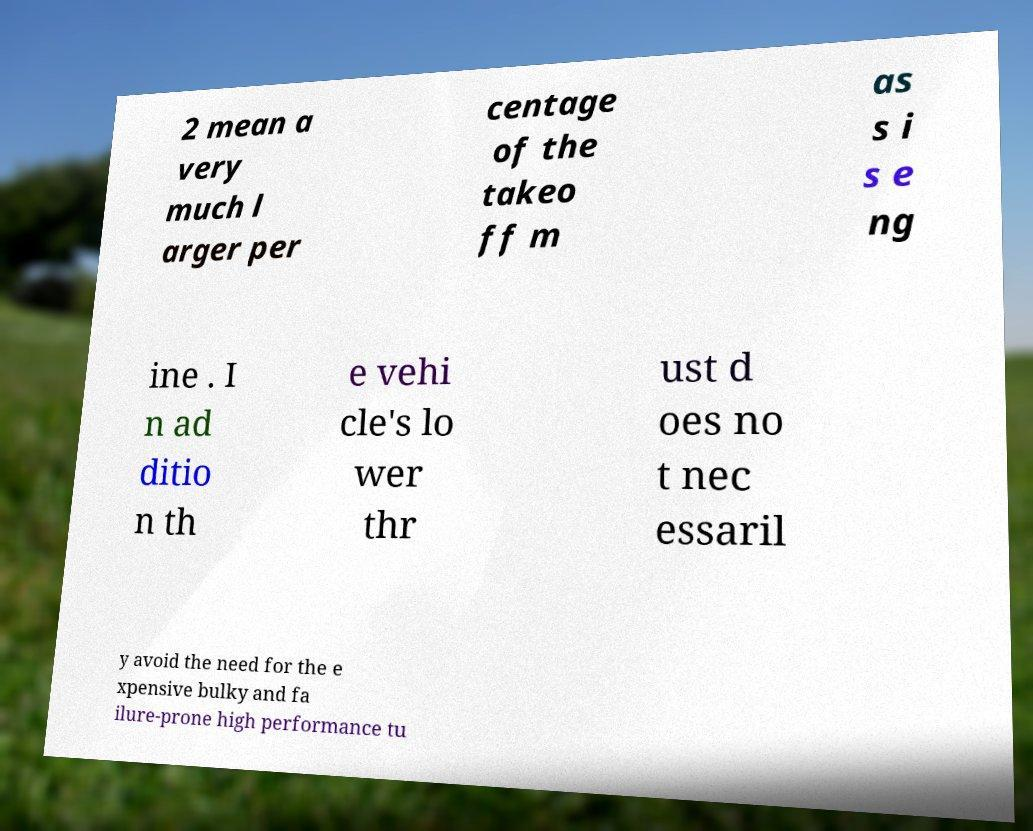Can you accurately transcribe the text from the provided image for me? 2 mean a very much l arger per centage of the takeo ff m as s i s e ng ine . I n ad ditio n th e vehi cle's lo wer thr ust d oes no t nec essaril y avoid the need for the e xpensive bulky and fa ilure-prone high performance tu 